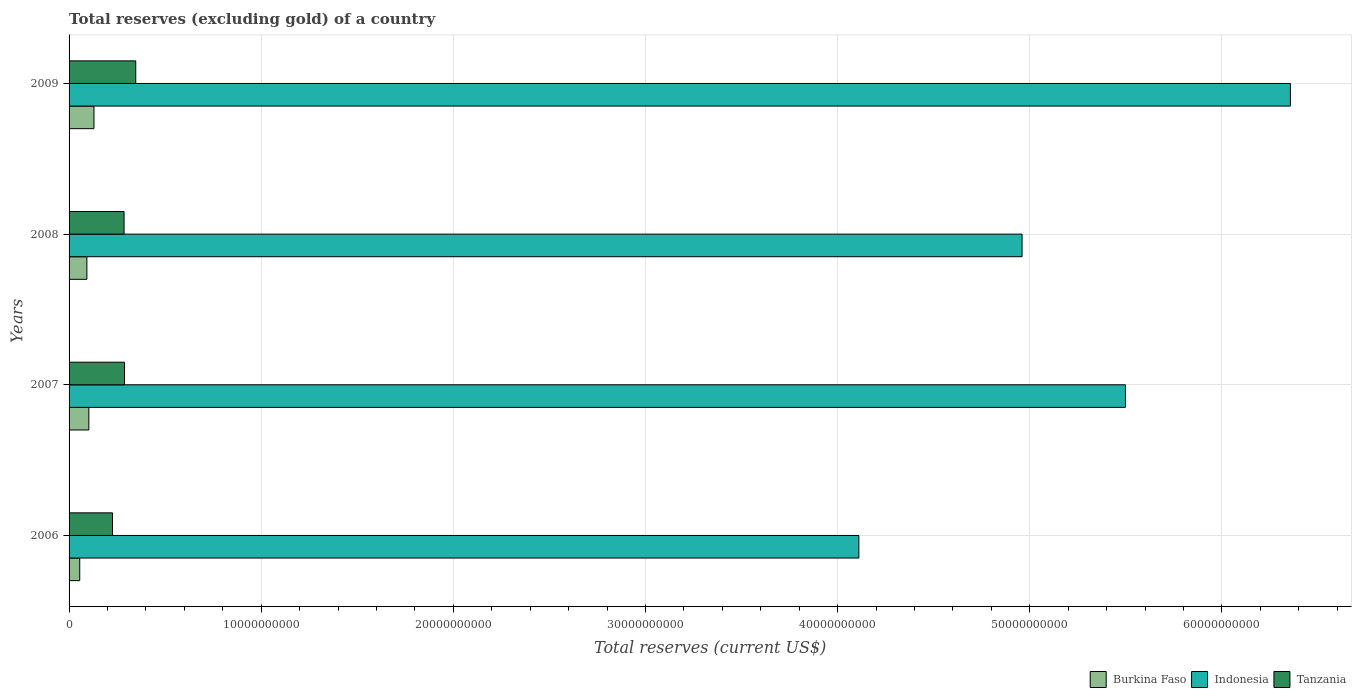How many different coloured bars are there?
Make the answer very short. 3. How many groups of bars are there?
Give a very brief answer. 4. Are the number of bars on each tick of the Y-axis equal?
Your response must be concise. Yes. How many bars are there on the 2nd tick from the bottom?
Your answer should be compact. 3. What is the total reserves (excluding gold) in Burkina Faso in 2009?
Offer a very short reply. 1.30e+09. Across all years, what is the maximum total reserves (excluding gold) in Tanzania?
Your answer should be compact. 3.47e+09. Across all years, what is the minimum total reserves (excluding gold) in Burkina Faso?
Your response must be concise. 5.55e+08. In which year was the total reserves (excluding gold) in Indonesia maximum?
Your response must be concise. 2009. In which year was the total reserves (excluding gold) in Indonesia minimum?
Offer a terse response. 2006. What is the total total reserves (excluding gold) in Indonesia in the graph?
Offer a terse response. 2.09e+11. What is the difference between the total reserves (excluding gold) in Tanzania in 2007 and that in 2009?
Keep it short and to the point. -5.84e+08. What is the difference between the total reserves (excluding gold) in Indonesia in 2009 and the total reserves (excluding gold) in Tanzania in 2008?
Your answer should be very brief. 6.07e+1. What is the average total reserves (excluding gold) in Burkina Faso per year?
Provide a short and direct response. 9.52e+08. In the year 2009, what is the difference between the total reserves (excluding gold) in Tanzania and total reserves (excluding gold) in Indonesia?
Offer a terse response. -6.01e+1. In how many years, is the total reserves (excluding gold) in Tanzania greater than 42000000000 US$?
Ensure brevity in your answer.  0. What is the ratio of the total reserves (excluding gold) in Burkina Faso in 2007 to that in 2009?
Provide a succinct answer. 0.79. Is the total reserves (excluding gold) in Burkina Faso in 2007 less than that in 2008?
Your answer should be compact. No. Is the difference between the total reserves (excluding gold) in Tanzania in 2007 and 2008 greater than the difference between the total reserves (excluding gold) in Indonesia in 2007 and 2008?
Your response must be concise. No. What is the difference between the highest and the second highest total reserves (excluding gold) in Indonesia?
Keep it short and to the point. 8.59e+09. What is the difference between the highest and the lowest total reserves (excluding gold) in Burkina Faso?
Your answer should be very brief. 7.41e+08. In how many years, is the total reserves (excluding gold) in Burkina Faso greater than the average total reserves (excluding gold) in Burkina Faso taken over all years?
Provide a succinct answer. 2. Is the sum of the total reserves (excluding gold) in Tanzania in 2007 and 2008 greater than the maximum total reserves (excluding gold) in Burkina Faso across all years?
Offer a very short reply. Yes. What does the 3rd bar from the top in 2007 represents?
Make the answer very short. Burkina Faso. What does the 3rd bar from the bottom in 2006 represents?
Give a very brief answer. Tanzania. Is it the case that in every year, the sum of the total reserves (excluding gold) in Tanzania and total reserves (excluding gold) in Burkina Faso is greater than the total reserves (excluding gold) in Indonesia?
Your answer should be compact. No. How many bars are there?
Your answer should be very brief. 12. Are all the bars in the graph horizontal?
Your answer should be very brief. Yes. How many years are there in the graph?
Provide a short and direct response. 4. What is the difference between two consecutive major ticks on the X-axis?
Offer a very short reply. 1.00e+1. Are the values on the major ticks of X-axis written in scientific E-notation?
Your answer should be compact. No. Does the graph contain any zero values?
Give a very brief answer. No. Does the graph contain grids?
Provide a short and direct response. Yes. Where does the legend appear in the graph?
Offer a terse response. Bottom right. How many legend labels are there?
Keep it short and to the point. 3. How are the legend labels stacked?
Your answer should be very brief. Horizontal. What is the title of the graph?
Your answer should be very brief. Total reserves (excluding gold) of a country. Does "Dominica" appear as one of the legend labels in the graph?
Offer a very short reply. No. What is the label or title of the X-axis?
Give a very brief answer. Total reserves (current US$). What is the Total reserves (current US$) of Burkina Faso in 2006?
Your response must be concise. 5.55e+08. What is the Total reserves (current US$) of Indonesia in 2006?
Your answer should be very brief. 4.11e+1. What is the Total reserves (current US$) in Tanzania in 2006?
Your response must be concise. 2.26e+09. What is the Total reserves (current US$) of Burkina Faso in 2007?
Give a very brief answer. 1.03e+09. What is the Total reserves (current US$) of Indonesia in 2007?
Make the answer very short. 5.50e+1. What is the Total reserves (current US$) of Tanzania in 2007?
Give a very brief answer. 2.89e+09. What is the Total reserves (current US$) in Burkina Faso in 2008?
Provide a succinct answer. 9.28e+08. What is the Total reserves (current US$) in Indonesia in 2008?
Offer a terse response. 4.96e+1. What is the Total reserves (current US$) of Tanzania in 2008?
Keep it short and to the point. 2.86e+09. What is the Total reserves (current US$) of Burkina Faso in 2009?
Your answer should be compact. 1.30e+09. What is the Total reserves (current US$) in Indonesia in 2009?
Your answer should be very brief. 6.36e+1. What is the Total reserves (current US$) of Tanzania in 2009?
Offer a very short reply. 3.47e+09. Across all years, what is the maximum Total reserves (current US$) in Burkina Faso?
Give a very brief answer. 1.30e+09. Across all years, what is the maximum Total reserves (current US$) in Indonesia?
Your answer should be compact. 6.36e+1. Across all years, what is the maximum Total reserves (current US$) in Tanzania?
Ensure brevity in your answer.  3.47e+09. Across all years, what is the minimum Total reserves (current US$) in Burkina Faso?
Your response must be concise. 5.55e+08. Across all years, what is the minimum Total reserves (current US$) in Indonesia?
Make the answer very short. 4.11e+1. Across all years, what is the minimum Total reserves (current US$) of Tanzania?
Offer a terse response. 2.26e+09. What is the total Total reserves (current US$) of Burkina Faso in the graph?
Make the answer very short. 3.81e+09. What is the total Total reserves (current US$) in Indonesia in the graph?
Offer a very short reply. 2.09e+11. What is the total Total reserves (current US$) of Tanzania in the graph?
Ensure brevity in your answer.  1.15e+1. What is the difference between the Total reserves (current US$) of Burkina Faso in 2006 and that in 2007?
Make the answer very short. -4.74e+08. What is the difference between the Total reserves (current US$) of Indonesia in 2006 and that in 2007?
Your answer should be very brief. -1.39e+1. What is the difference between the Total reserves (current US$) of Tanzania in 2006 and that in 2007?
Give a very brief answer. -6.27e+08. What is the difference between the Total reserves (current US$) of Burkina Faso in 2006 and that in 2008?
Your answer should be compact. -3.73e+08. What is the difference between the Total reserves (current US$) of Indonesia in 2006 and that in 2008?
Your answer should be very brief. -8.49e+09. What is the difference between the Total reserves (current US$) of Tanzania in 2006 and that in 2008?
Your answer should be compact. -6.04e+08. What is the difference between the Total reserves (current US$) of Burkina Faso in 2006 and that in 2009?
Offer a terse response. -7.41e+08. What is the difference between the Total reserves (current US$) of Indonesia in 2006 and that in 2009?
Your answer should be compact. -2.25e+1. What is the difference between the Total reserves (current US$) of Tanzania in 2006 and that in 2009?
Offer a terse response. -1.21e+09. What is the difference between the Total reserves (current US$) of Burkina Faso in 2007 and that in 2008?
Offer a very short reply. 1.02e+08. What is the difference between the Total reserves (current US$) in Indonesia in 2007 and that in 2008?
Your answer should be very brief. 5.38e+09. What is the difference between the Total reserves (current US$) of Tanzania in 2007 and that in 2008?
Provide a succinct answer. 2.35e+07. What is the difference between the Total reserves (current US$) in Burkina Faso in 2007 and that in 2009?
Keep it short and to the point. -2.67e+08. What is the difference between the Total reserves (current US$) of Indonesia in 2007 and that in 2009?
Offer a terse response. -8.59e+09. What is the difference between the Total reserves (current US$) in Tanzania in 2007 and that in 2009?
Provide a succinct answer. -5.84e+08. What is the difference between the Total reserves (current US$) in Burkina Faso in 2008 and that in 2009?
Keep it short and to the point. -3.68e+08. What is the difference between the Total reserves (current US$) of Indonesia in 2008 and that in 2009?
Your answer should be very brief. -1.40e+1. What is the difference between the Total reserves (current US$) of Tanzania in 2008 and that in 2009?
Make the answer very short. -6.08e+08. What is the difference between the Total reserves (current US$) of Burkina Faso in 2006 and the Total reserves (current US$) of Indonesia in 2007?
Provide a succinct answer. -5.44e+1. What is the difference between the Total reserves (current US$) of Burkina Faso in 2006 and the Total reserves (current US$) of Tanzania in 2007?
Your answer should be very brief. -2.33e+09. What is the difference between the Total reserves (current US$) in Indonesia in 2006 and the Total reserves (current US$) in Tanzania in 2007?
Offer a very short reply. 3.82e+1. What is the difference between the Total reserves (current US$) in Burkina Faso in 2006 and the Total reserves (current US$) in Indonesia in 2008?
Provide a succinct answer. -4.90e+1. What is the difference between the Total reserves (current US$) of Burkina Faso in 2006 and the Total reserves (current US$) of Tanzania in 2008?
Your response must be concise. -2.31e+09. What is the difference between the Total reserves (current US$) of Indonesia in 2006 and the Total reserves (current US$) of Tanzania in 2008?
Ensure brevity in your answer.  3.82e+1. What is the difference between the Total reserves (current US$) in Burkina Faso in 2006 and the Total reserves (current US$) in Indonesia in 2009?
Keep it short and to the point. -6.30e+1. What is the difference between the Total reserves (current US$) in Burkina Faso in 2006 and the Total reserves (current US$) in Tanzania in 2009?
Your answer should be very brief. -2.92e+09. What is the difference between the Total reserves (current US$) of Indonesia in 2006 and the Total reserves (current US$) of Tanzania in 2009?
Make the answer very short. 3.76e+1. What is the difference between the Total reserves (current US$) in Burkina Faso in 2007 and the Total reserves (current US$) in Indonesia in 2008?
Your answer should be compact. -4.86e+1. What is the difference between the Total reserves (current US$) of Burkina Faso in 2007 and the Total reserves (current US$) of Tanzania in 2008?
Your answer should be compact. -1.83e+09. What is the difference between the Total reserves (current US$) of Indonesia in 2007 and the Total reserves (current US$) of Tanzania in 2008?
Provide a short and direct response. 5.21e+1. What is the difference between the Total reserves (current US$) in Burkina Faso in 2007 and the Total reserves (current US$) in Indonesia in 2009?
Provide a short and direct response. -6.25e+1. What is the difference between the Total reserves (current US$) of Burkina Faso in 2007 and the Total reserves (current US$) of Tanzania in 2009?
Offer a terse response. -2.44e+09. What is the difference between the Total reserves (current US$) of Indonesia in 2007 and the Total reserves (current US$) of Tanzania in 2009?
Ensure brevity in your answer.  5.15e+1. What is the difference between the Total reserves (current US$) in Burkina Faso in 2008 and the Total reserves (current US$) in Indonesia in 2009?
Ensure brevity in your answer.  -6.26e+1. What is the difference between the Total reserves (current US$) in Burkina Faso in 2008 and the Total reserves (current US$) in Tanzania in 2009?
Offer a very short reply. -2.54e+09. What is the difference between the Total reserves (current US$) of Indonesia in 2008 and the Total reserves (current US$) of Tanzania in 2009?
Offer a terse response. 4.61e+1. What is the average Total reserves (current US$) in Burkina Faso per year?
Your answer should be very brief. 9.52e+08. What is the average Total reserves (current US$) in Indonesia per year?
Provide a short and direct response. 5.23e+1. What is the average Total reserves (current US$) in Tanzania per year?
Ensure brevity in your answer.  2.87e+09. In the year 2006, what is the difference between the Total reserves (current US$) of Burkina Faso and Total reserves (current US$) of Indonesia?
Provide a short and direct response. -4.05e+1. In the year 2006, what is the difference between the Total reserves (current US$) of Burkina Faso and Total reserves (current US$) of Tanzania?
Your response must be concise. -1.70e+09. In the year 2006, what is the difference between the Total reserves (current US$) of Indonesia and Total reserves (current US$) of Tanzania?
Make the answer very short. 3.88e+1. In the year 2007, what is the difference between the Total reserves (current US$) in Burkina Faso and Total reserves (current US$) in Indonesia?
Your response must be concise. -5.39e+1. In the year 2007, what is the difference between the Total reserves (current US$) in Burkina Faso and Total reserves (current US$) in Tanzania?
Provide a succinct answer. -1.86e+09. In the year 2007, what is the difference between the Total reserves (current US$) of Indonesia and Total reserves (current US$) of Tanzania?
Offer a very short reply. 5.21e+1. In the year 2008, what is the difference between the Total reserves (current US$) in Burkina Faso and Total reserves (current US$) in Indonesia?
Your answer should be very brief. -4.87e+1. In the year 2008, what is the difference between the Total reserves (current US$) in Burkina Faso and Total reserves (current US$) in Tanzania?
Offer a very short reply. -1.94e+09. In the year 2008, what is the difference between the Total reserves (current US$) in Indonesia and Total reserves (current US$) in Tanzania?
Offer a very short reply. 4.67e+1. In the year 2009, what is the difference between the Total reserves (current US$) of Burkina Faso and Total reserves (current US$) of Indonesia?
Provide a succinct answer. -6.23e+1. In the year 2009, what is the difference between the Total reserves (current US$) of Burkina Faso and Total reserves (current US$) of Tanzania?
Your response must be concise. -2.17e+09. In the year 2009, what is the difference between the Total reserves (current US$) of Indonesia and Total reserves (current US$) of Tanzania?
Give a very brief answer. 6.01e+1. What is the ratio of the Total reserves (current US$) in Burkina Faso in 2006 to that in 2007?
Your answer should be compact. 0.54. What is the ratio of the Total reserves (current US$) in Indonesia in 2006 to that in 2007?
Give a very brief answer. 0.75. What is the ratio of the Total reserves (current US$) of Tanzania in 2006 to that in 2007?
Provide a succinct answer. 0.78. What is the ratio of the Total reserves (current US$) in Burkina Faso in 2006 to that in 2008?
Your answer should be compact. 0.6. What is the ratio of the Total reserves (current US$) of Indonesia in 2006 to that in 2008?
Ensure brevity in your answer.  0.83. What is the ratio of the Total reserves (current US$) of Tanzania in 2006 to that in 2008?
Offer a very short reply. 0.79. What is the ratio of the Total reserves (current US$) of Burkina Faso in 2006 to that in 2009?
Keep it short and to the point. 0.43. What is the ratio of the Total reserves (current US$) in Indonesia in 2006 to that in 2009?
Keep it short and to the point. 0.65. What is the ratio of the Total reserves (current US$) of Tanzania in 2006 to that in 2009?
Provide a succinct answer. 0.65. What is the ratio of the Total reserves (current US$) of Burkina Faso in 2007 to that in 2008?
Give a very brief answer. 1.11. What is the ratio of the Total reserves (current US$) in Indonesia in 2007 to that in 2008?
Your answer should be compact. 1.11. What is the ratio of the Total reserves (current US$) of Tanzania in 2007 to that in 2008?
Ensure brevity in your answer.  1.01. What is the ratio of the Total reserves (current US$) in Burkina Faso in 2007 to that in 2009?
Your response must be concise. 0.79. What is the ratio of the Total reserves (current US$) of Indonesia in 2007 to that in 2009?
Your answer should be very brief. 0.86. What is the ratio of the Total reserves (current US$) of Tanzania in 2007 to that in 2009?
Your response must be concise. 0.83. What is the ratio of the Total reserves (current US$) in Burkina Faso in 2008 to that in 2009?
Your response must be concise. 0.72. What is the ratio of the Total reserves (current US$) in Indonesia in 2008 to that in 2009?
Ensure brevity in your answer.  0.78. What is the ratio of the Total reserves (current US$) in Tanzania in 2008 to that in 2009?
Provide a succinct answer. 0.82. What is the difference between the highest and the second highest Total reserves (current US$) of Burkina Faso?
Your answer should be compact. 2.67e+08. What is the difference between the highest and the second highest Total reserves (current US$) in Indonesia?
Your answer should be compact. 8.59e+09. What is the difference between the highest and the second highest Total reserves (current US$) of Tanzania?
Keep it short and to the point. 5.84e+08. What is the difference between the highest and the lowest Total reserves (current US$) in Burkina Faso?
Keep it short and to the point. 7.41e+08. What is the difference between the highest and the lowest Total reserves (current US$) of Indonesia?
Your answer should be compact. 2.25e+1. What is the difference between the highest and the lowest Total reserves (current US$) in Tanzania?
Your answer should be compact. 1.21e+09. 